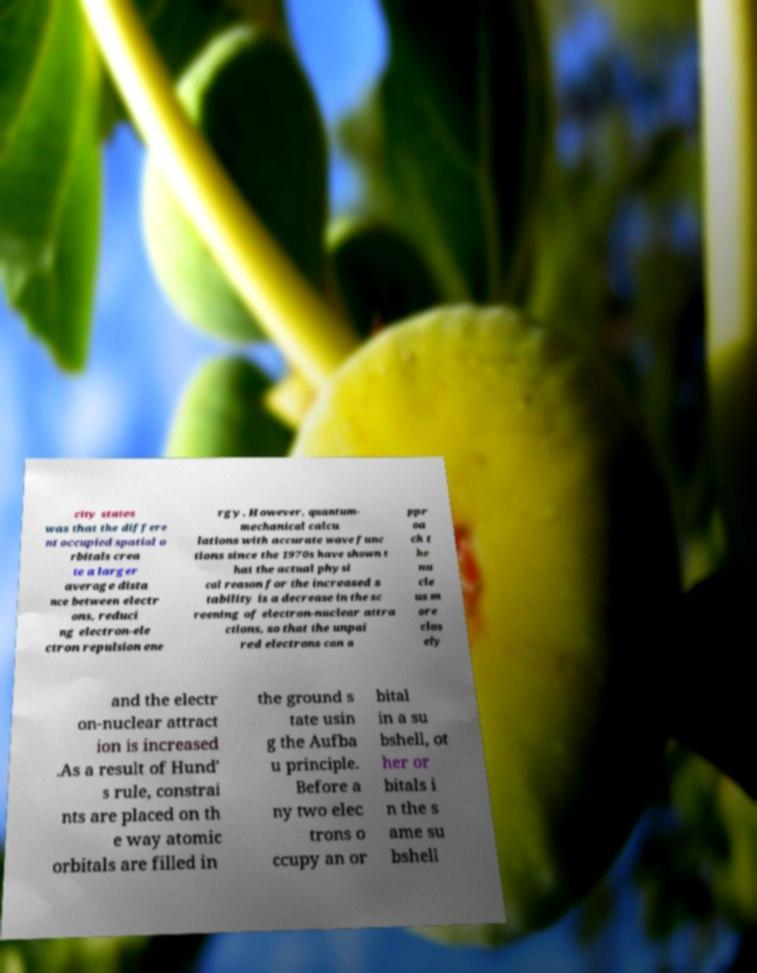What messages or text are displayed in this image? I need them in a readable, typed format. city states was that the differe nt occupied spatial o rbitals crea te a larger average dista nce between electr ons, reduci ng electron-ele ctron repulsion ene rgy. However, quantum- mechanical calcu lations with accurate wave func tions since the 1970s have shown t hat the actual physi cal reason for the increased s tability is a decrease in the sc reening of electron-nuclear attra ctions, so that the unpai red electrons can a ppr oa ch t he nu cle us m ore clos ely and the electr on-nuclear attract ion is increased .As a result of Hund' s rule, constrai nts are placed on th e way atomic orbitals are filled in the ground s tate usin g the Aufba u principle. Before a ny two elec trons o ccupy an or bital in a su bshell, ot her or bitals i n the s ame su bshell 